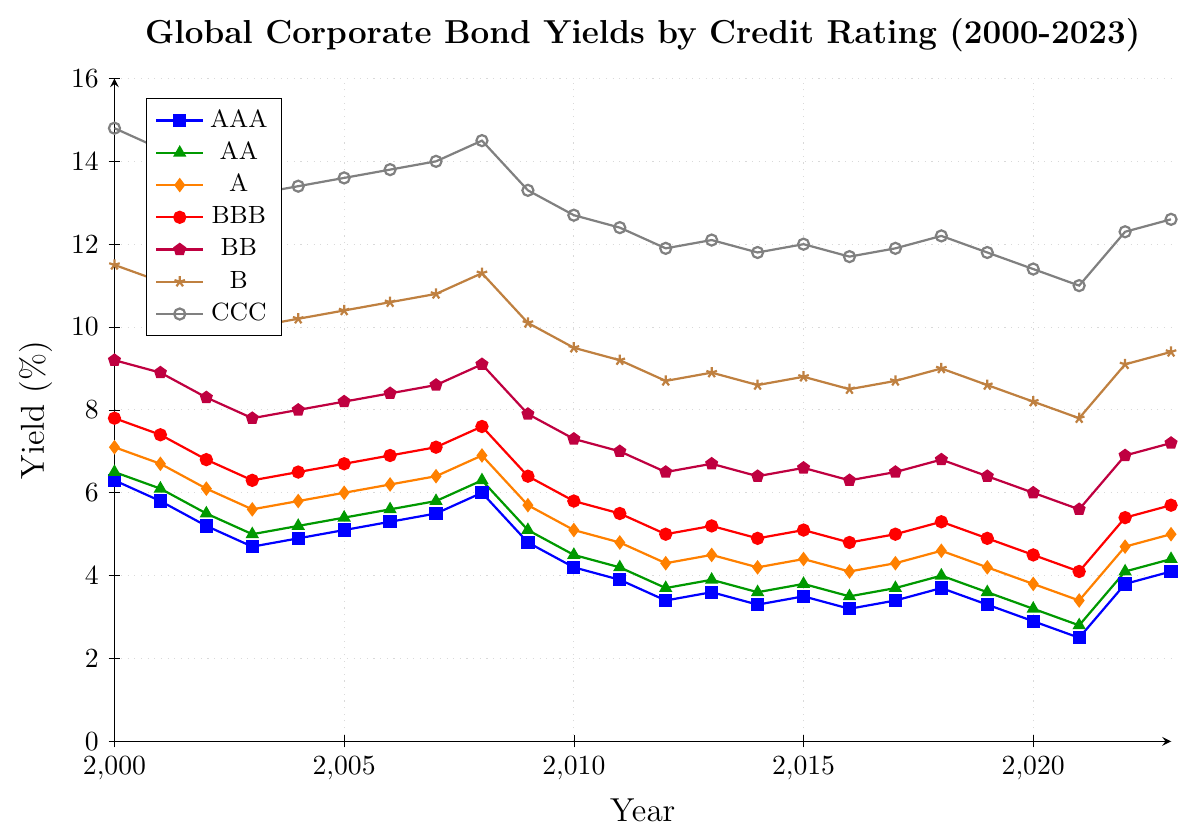What is the general trend in the yields of AAA-rated bonds from 2000 to 2023? Viewing the plot, we observe that the yield of AAA-rated bonds consistently declines from 2000 (~6.3%) to 2021 (~2.5%). In the last two years shown, the yield increases to around 4.1% by 2023.
Answer: The general trend shows a decline until 2021, followed by a slight increase Which credit rating had the highest yield in 2020, and what was the approximate percentage difference between the highest and the lowest yields that year? The CCC-rated bonds had the highest yield in 2020 (~11.4%), and the AAA-rated bonds had the lowest yield (~2.9%). The difference between the two is calculated as 11.4% - 2.9% = 8.5%.
Answer: CCC; 8.5% How did the yield of BBB-rated bonds change between 2008 and 2009? The yield of BBB-rated bonds decreased from 7.6% in 2008 to 6.4% in 2009. To find the change: 7.6% (2008) - 6.4% (2009) = 1.2% decrease.
Answer: It decreased by 1.2% Compare the yields of AA and BBB-rated bonds in 2023. Which yield was higher and by how much? The plot shows that the yield for AA-rated bonds in 2023 (~4.4%) was lower than the yield for BBB-rated bonds (~5.7%). The difference between them is 5.7% - 4.4% = 1.3%.
Answer: BBB; 1.3% Which credit rating had the most significant yield decrease between 2000 and 2012? By examining the plot, we notice that the CCC-rated bonds had a yield decrease from ~14.8% (2000) to ~11.9% (2012). Calculate the decrease: 14.8% - 11.9% = 2.9%. Other ratings show relatively smaller decreases.
Answer: CCC; 2.9% Identify the credit rating with the fastest yield growth from 2021 to 2023 and provide the growth rate. The plot indicates that BBB-rated bonds saw the most rapid growth, increasing from ~4.1% (2021) to ~5.7% (2023). Calculate the growth rate: 5.7% - 4.1% = 1.6%.
Answer: BBB; 1.6% What is the average yield of A-rated bonds in the years 2015 through 2017? First, find the yields for A-rated bonds in 2015 (4.4%), 2016 (4.1%), and 2017 (4.3%). Calculate the average: (4.4% + 4.1% + 4.3%) / 3 = 4.27%.
Answer: 4.27% Which year saw the lowest yield for B-rated bonds and what was the yield? The plot shows the lowest yield for B-rated bonds was in 2021 (~7.8%).
Answer: 2021; 7.8% Compare the yield pattern between AA-rated and BB-rated bonds from 2000 to 2023. What can you infer about the credit risk associated with these categories over the given period? AA-rated bonds consistently have lower yields than BB-rated bonds throughout the period, indicating lower credit risk for AA-rated bonds. Over time, both categories show a general downward trend with slight fluctuations, but BB-rated bonds always remained higher, reflecting higher inherent risk.
Answer: AA-rated bonds consistently indicate lower credit risk Calculate the difference in the average yields of bonds rated AAA and CCC over the entire period (2000-2023). First, calculate the averages for both ratings over the years. Sum of AAA yields: 94.7, and CCC yields: 292.2. There are 24 years, so the average for AAA is 94.7/24 ≈ 3.95%, and for CCC, it is 292.2/24 ≈ 12.18%. The difference is 12.18% - 3.95% = 8.23%.
Answer: 8.23% 